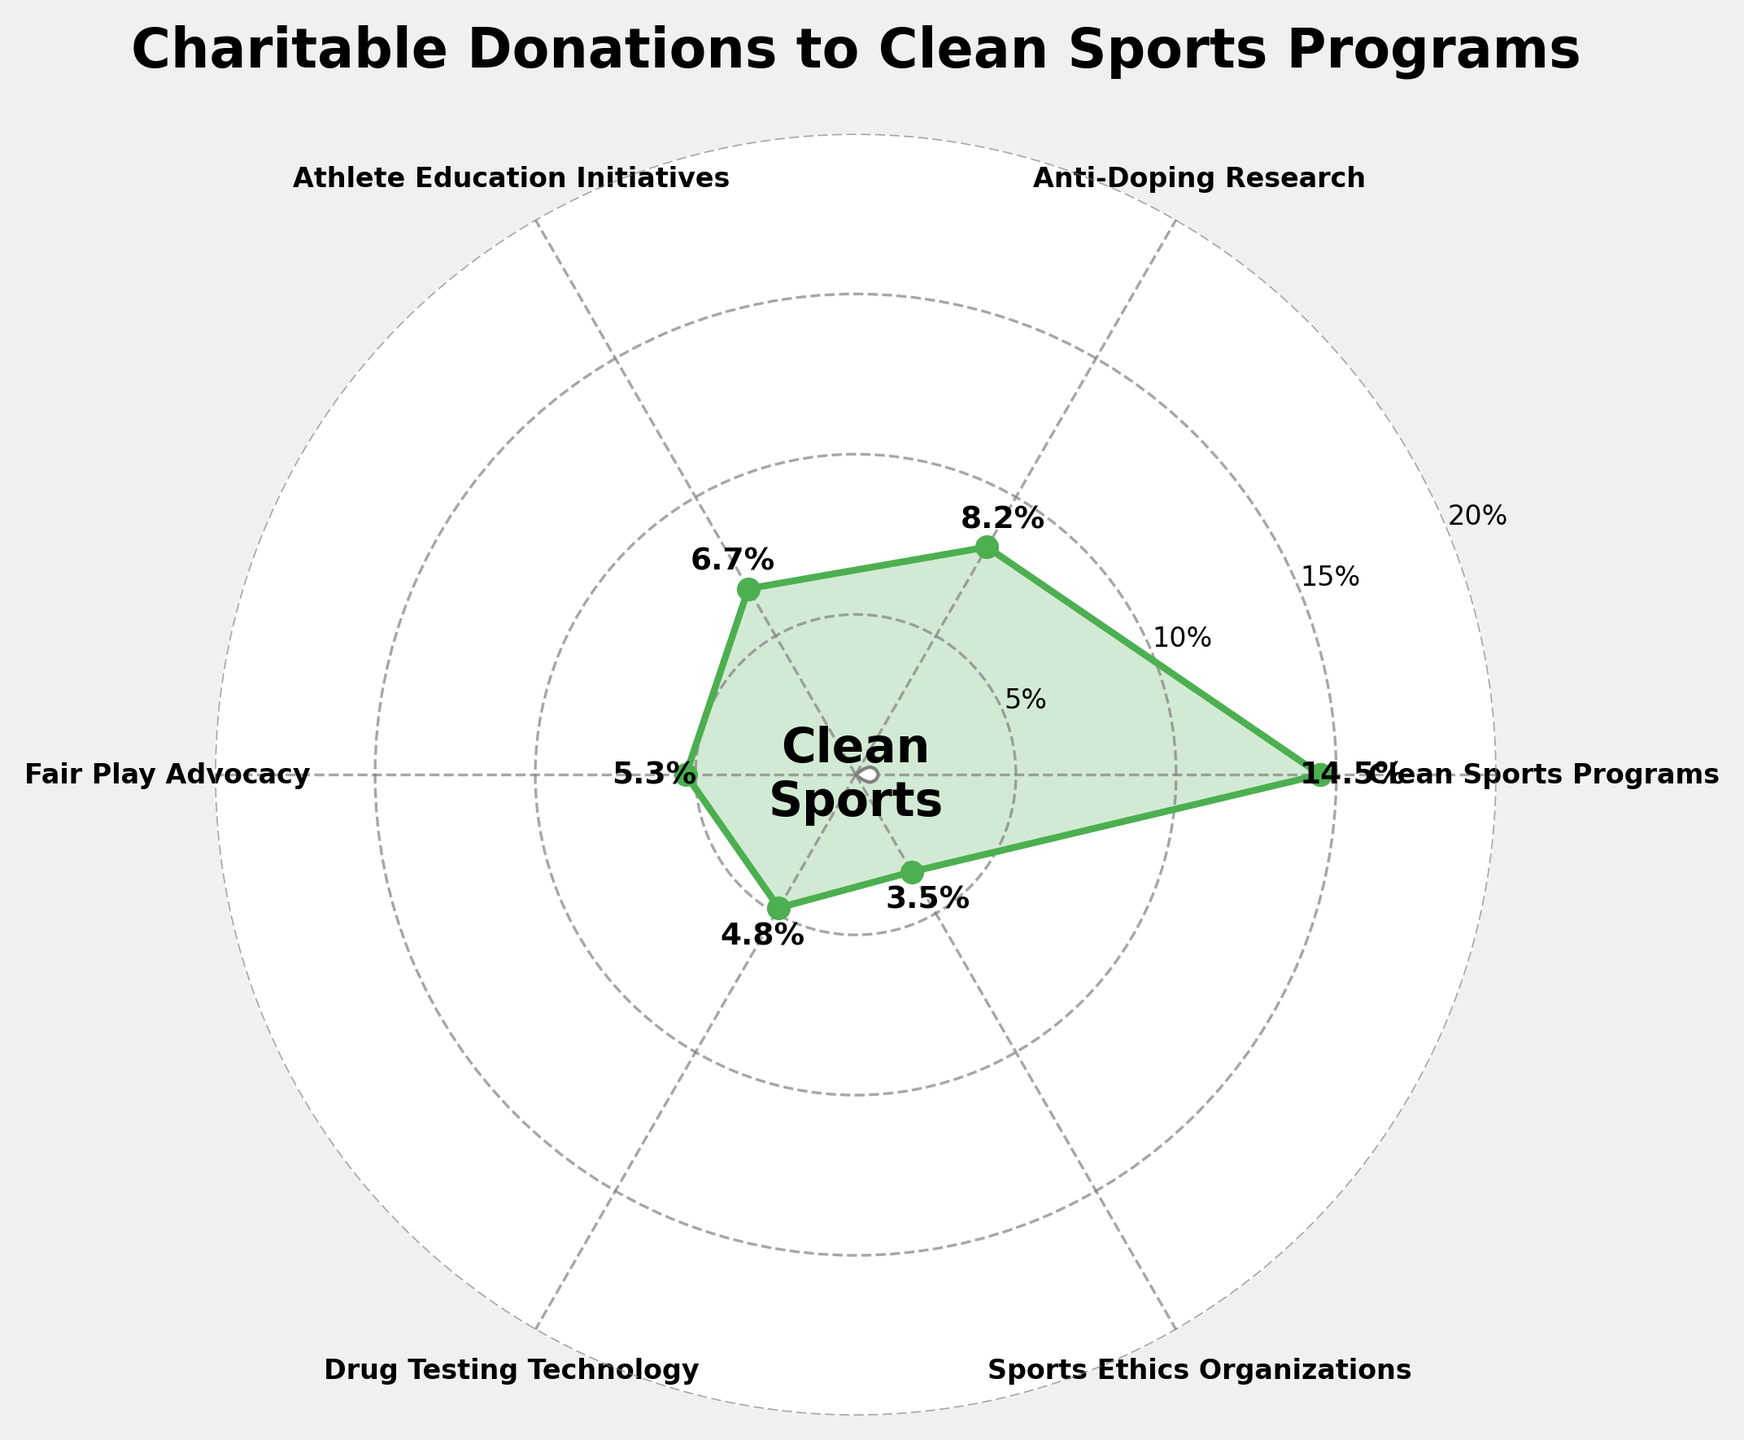What's the title of the figure? The title can be found at the top center of the figure. It summarizes the content and focus of the chart.
Answer: Charitable Donations to Clean Sports Programs How many categories are displayed in the figure? By counting the labels or wedges around the circular plot, we can determine the number of distinct categories presented.
Answer: Six Which category received the highest percentage of charitable donations? The category with the highest value indicated at the outer edge (14.5%) is the one that received the most donations.
Answer: Clean Sports Programs What is the difference in percentage between Athlete Education Initiatives and Drug Testing Technology? Athlete Education Initiatives has 6.7%, and Drug Testing Technology has 4.8%. The difference is calculated as 6.7% - 4.8%.
Answer: 1.9% How do the percentages of Anti-Doping Research and Fair Play Advocacy compare? Anti-Doping Research stands at 8.2% and Fair Play Advocacy at 5.3%. Comparing the values, Anti-Doping Research is higher.
Answer: Anti-Doping Research is higher What is the combined percentage of donations for Fair Play Advocacy and Sports Ethics Organizations? Adding the percentages of Fair Play Advocacy (5.3%) and Sports Ethics Organizations (3.5%) together gives the combined percentage.
Answer: 8.8% What's the average percentage of all the categories represented in the chart? Sum all the percentages (14.5 + 8.2 + 6.7 + 5.3 + 4.8 + 3.5) to get 43. Then, divide by the number of categories (6).
Answer: 7.17% How many categories received less than 5% of the total donations? By identifying categories with percentages below 5%: Drug Testing Technology (4.8%) and Sports Ethics Organizations (3.5%) are the ones fitting this criterion.
Answer: Two What is the smallest percentage displayed and which category does it correspond to? The smallest value displayed on the chart is 3.5%. We look at the corresponding category.
Answer: 3.5%, Sports Ethics Organizations What range of values is displayed on the y-axis? The y-axis ticks indicate the range, starting from the base and extending to the highest tick mark.
Answer: 0% to 20% 